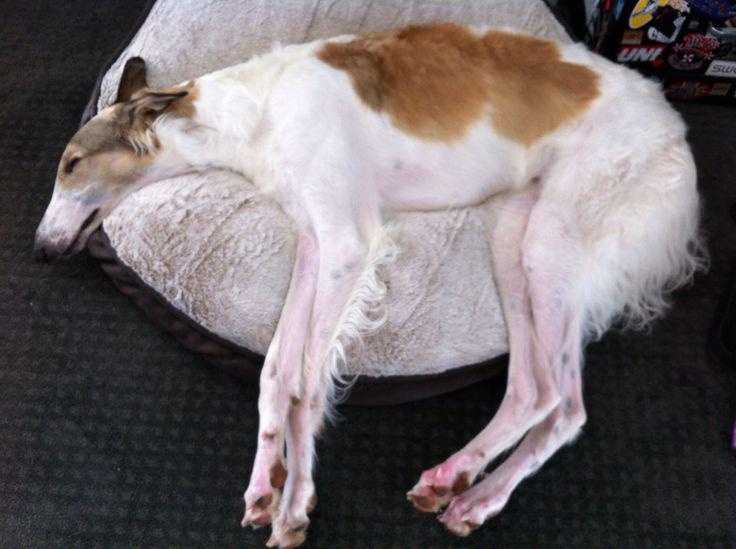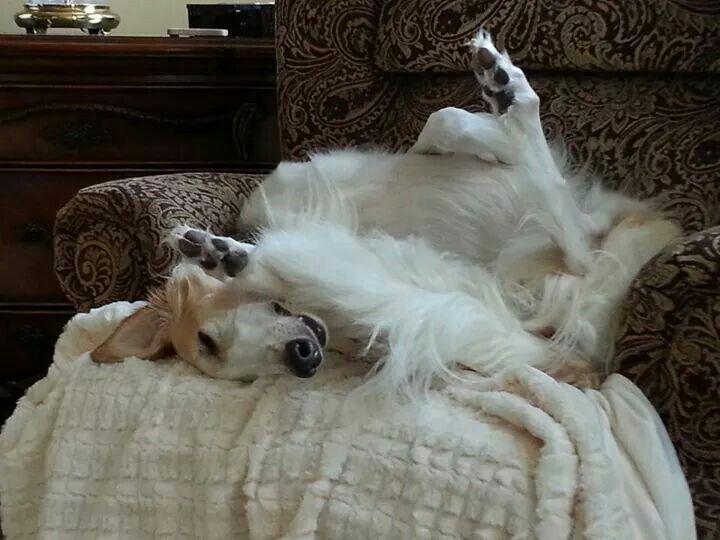The first image is the image on the left, the second image is the image on the right. For the images displayed, is the sentence "The dog in the image on the right is lying on a couch." factually correct? Answer yes or no. No. The first image is the image on the left, the second image is the image on the right. For the images shown, is this caption "A dog is lying on the floor on a rug." true? Answer yes or no. No. 